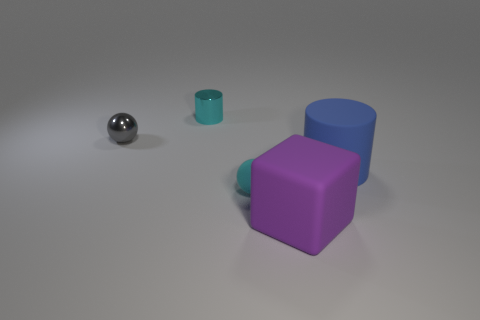Add 3 big rubber cylinders. How many objects exist? 8 Subtract all cylinders. How many objects are left? 3 Subtract 1 cyan cylinders. How many objects are left? 4 Subtract all matte spheres. Subtract all large objects. How many objects are left? 2 Add 5 cyan metallic objects. How many cyan metallic objects are left? 6 Add 2 cylinders. How many cylinders exist? 4 